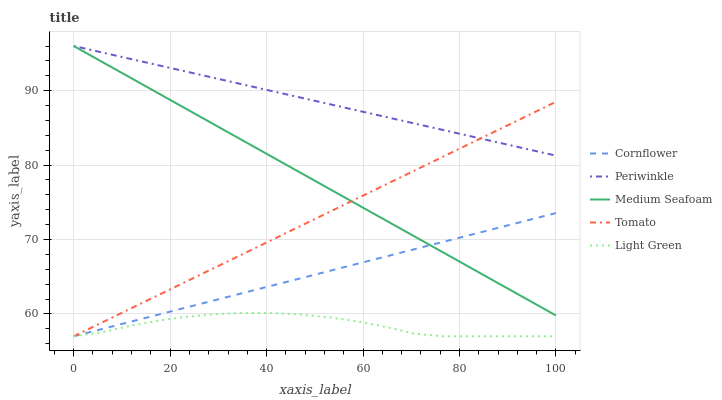Does Light Green have the minimum area under the curve?
Answer yes or no. Yes. Does Periwinkle have the maximum area under the curve?
Answer yes or no. Yes. Does Cornflower have the minimum area under the curve?
Answer yes or no. No. Does Cornflower have the maximum area under the curve?
Answer yes or no. No. Is Periwinkle the smoothest?
Answer yes or no. Yes. Is Light Green the roughest?
Answer yes or no. Yes. Is Cornflower the smoothest?
Answer yes or no. No. Is Cornflower the roughest?
Answer yes or no. No. Does Tomato have the lowest value?
Answer yes or no. Yes. Does Periwinkle have the lowest value?
Answer yes or no. No. Does Medium Seafoam have the highest value?
Answer yes or no. Yes. Does Cornflower have the highest value?
Answer yes or no. No. Is Light Green less than Medium Seafoam?
Answer yes or no. Yes. Is Medium Seafoam greater than Light Green?
Answer yes or no. Yes. Does Medium Seafoam intersect Periwinkle?
Answer yes or no. Yes. Is Medium Seafoam less than Periwinkle?
Answer yes or no. No. Is Medium Seafoam greater than Periwinkle?
Answer yes or no. No. Does Light Green intersect Medium Seafoam?
Answer yes or no. No. 